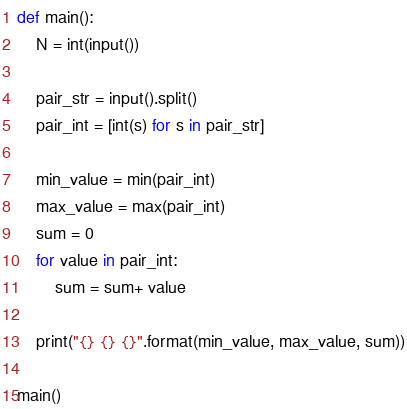Convert code to text. <code><loc_0><loc_0><loc_500><loc_500><_Python_>def main():
    N = int(input())

    pair_str = input().split()
    pair_int = [int(s) for s in pair_str]

    min_value = min(pair_int)
    max_value = max(pair_int)
    sum = 0
    for value in pair_int:
        sum = sum+ value

    print("{} {} {}".format(min_value, max_value, sum))

main()

</code> 